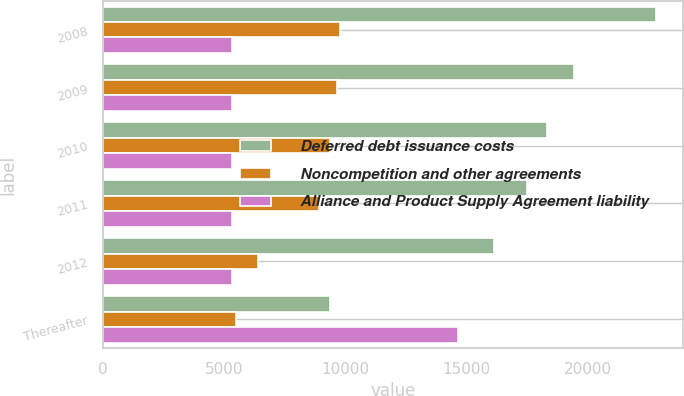<chart> <loc_0><loc_0><loc_500><loc_500><stacked_bar_chart><ecel><fcel>2008<fcel>2009<fcel>2010<fcel>2011<fcel>2012<fcel>Thereafter<nl><fcel>Deferred debt issuance costs<fcel>22808<fcel>19428<fcel>18340<fcel>17488<fcel>16138<fcel>9374<nl><fcel>Noncompetition and other agreements<fcel>9772<fcel>9646<fcel>9374<fcel>8914<fcel>6418<fcel>5510<nl><fcel>Alliance and Product Supply Agreement liability<fcel>5330<fcel>5330<fcel>5330<fcel>5330<fcel>5330<fcel>14657<nl></chart> 